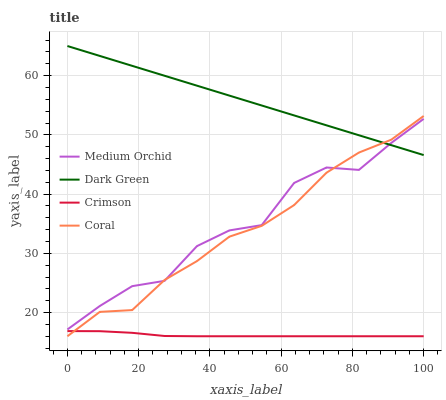Does Crimson have the minimum area under the curve?
Answer yes or no. Yes. Does Dark Green have the maximum area under the curve?
Answer yes or no. Yes. Does Coral have the minimum area under the curve?
Answer yes or no. No. Does Coral have the maximum area under the curve?
Answer yes or no. No. Is Dark Green the smoothest?
Answer yes or no. Yes. Is Medium Orchid the roughest?
Answer yes or no. Yes. Is Coral the smoothest?
Answer yes or no. No. Is Coral the roughest?
Answer yes or no. No. Does Crimson have the lowest value?
Answer yes or no. Yes. Does Medium Orchid have the lowest value?
Answer yes or no. No. Does Dark Green have the highest value?
Answer yes or no. Yes. Does Coral have the highest value?
Answer yes or no. No. Is Crimson less than Medium Orchid?
Answer yes or no. Yes. Is Medium Orchid greater than Crimson?
Answer yes or no. Yes. Does Coral intersect Dark Green?
Answer yes or no. Yes. Is Coral less than Dark Green?
Answer yes or no. No. Is Coral greater than Dark Green?
Answer yes or no. No. Does Crimson intersect Medium Orchid?
Answer yes or no. No. 